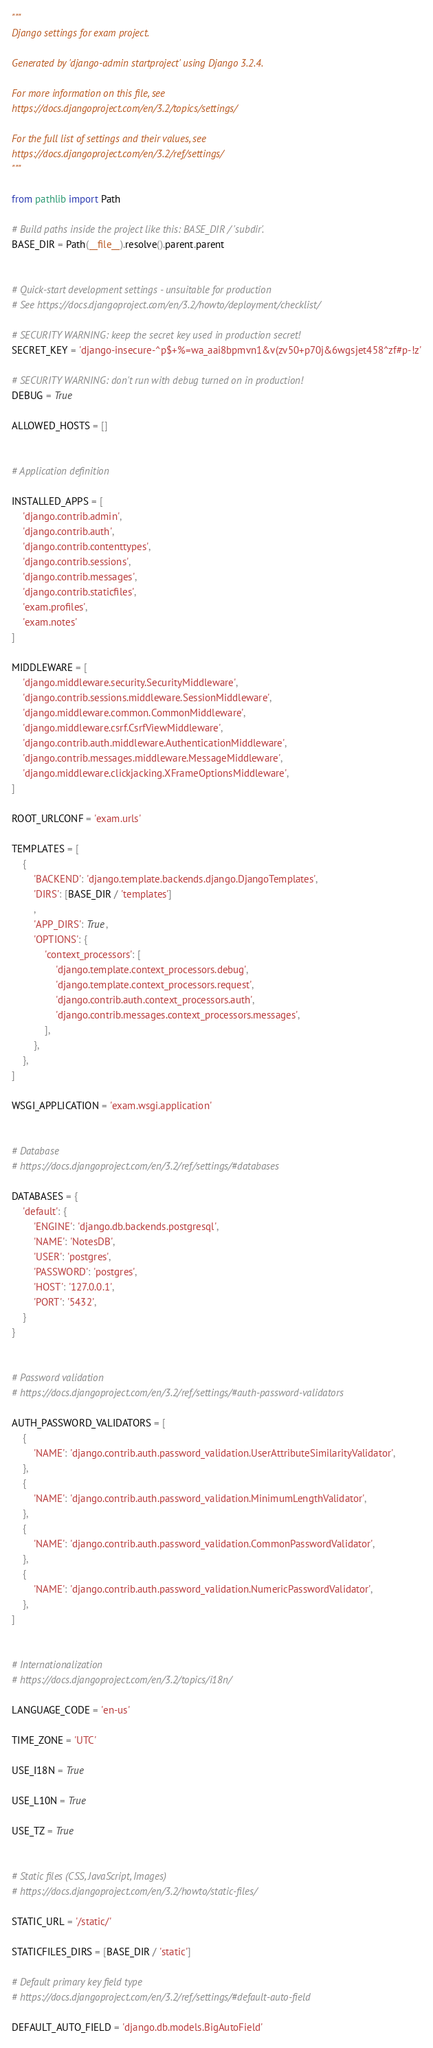<code> <loc_0><loc_0><loc_500><loc_500><_Python_>"""
Django settings for exam project.

Generated by 'django-admin startproject' using Django 3.2.4.

For more information on this file, see
https://docs.djangoproject.com/en/3.2/topics/settings/

For the full list of settings and their values, see
https://docs.djangoproject.com/en/3.2/ref/settings/
"""

from pathlib import Path

# Build paths inside the project like this: BASE_DIR / 'subdir'.
BASE_DIR = Path(__file__).resolve().parent.parent


# Quick-start development settings - unsuitable for production
# See https://docs.djangoproject.com/en/3.2/howto/deployment/checklist/

# SECURITY WARNING: keep the secret key used in production secret!
SECRET_KEY = 'django-insecure-^p$+%=wa_aai8bpmvn1&v(zv50+p70j&6wgsjet458^zf#p-!z'

# SECURITY WARNING: don't run with debug turned on in production!
DEBUG = True

ALLOWED_HOSTS = []


# Application definition

INSTALLED_APPS = [
    'django.contrib.admin',
    'django.contrib.auth',
    'django.contrib.contenttypes',
    'django.contrib.sessions',
    'django.contrib.messages',
    'django.contrib.staticfiles',
    'exam.profiles',
    'exam.notes'
]

MIDDLEWARE = [
    'django.middleware.security.SecurityMiddleware',
    'django.contrib.sessions.middleware.SessionMiddleware',
    'django.middleware.common.CommonMiddleware',
    'django.middleware.csrf.CsrfViewMiddleware',
    'django.contrib.auth.middleware.AuthenticationMiddleware',
    'django.contrib.messages.middleware.MessageMiddleware',
    'django.middleware.clickjacking.XFrameOptionsMiddleware',
]

ROOT_URLCONF = 'exam.urls'

TEMPLATES = [
    {
        'BACKEND': 'django.template.backends.django.DjangoTemplates',
        'DIRS': [BASE_DIR / 'templates']
        ,
        'APP_DIRS': True,
        'OPTIONS': {
            'context_processors': [
                'django.template.context_processors.debug',
                'django.template.context_processors.request',
                'django.contrib.auth.context_processors.auth',
                'django.contrib.messages.context_processors.messages',
            ],
        },
    },
]

WSGI_APPLICATION = 'exam.wsgi.application'


# Database
# https://docs.djangoproject.com/en/3.2/ref/settings/#databases

DATABASES = {
    'default': {
        'ENGINE': 'django.db.backends.postgresql',
        'NAME': 'NotesDB',
        'USER': 'postgres',
        'PASSWORD': 'postgres',
        'HOST': '127.0.0.1',
        'PORT': '5432',
    }
}


# Password validation
# https://docs.djangoproject.com/en/3.2/ref/settings/#auth-password-validators

AUTH_PASSWORD_VALIDATORS = [
    {
        'NAME': 'django.contrib.auth.password_validation.UserAttributeSimilarityValidator',
    },
    {
        'NAME': 'django.contrib.auth.password_validation.MinimumLengthValidator',
    },
    {
        'NAME': 'django.contrib.auth.password_validation.CommonPasswordValidator',
    },
    {
        'NAME': 'django.contrib.auth.password_validation.NumericPasswordValidator',
    },
]


# Internationalization
# https://docs.djangoproject.com/en/3.2/topics/i18n/

LANGUAGE_CODE = 'en-us'

TIME_ZONE = 'UTC'

USE_I18N = True

USE_L10N = True

USE_TZ = True


# Static files (CSS, JavaScript, Images)
# https://docs.djangoproject.com/en/3.2/howto/static-files/

STATIC_URL = '/static/'

STATICFILES_DIRS = [BASE_DIR / 'static']

# Default primary key field type
# https://docs.djangoproject.com/en/3.2/ref/settings/#default-auto-field

DEFAULT_AUTO_FIELD = 'django.db.models.BigAutoField'
</code> 